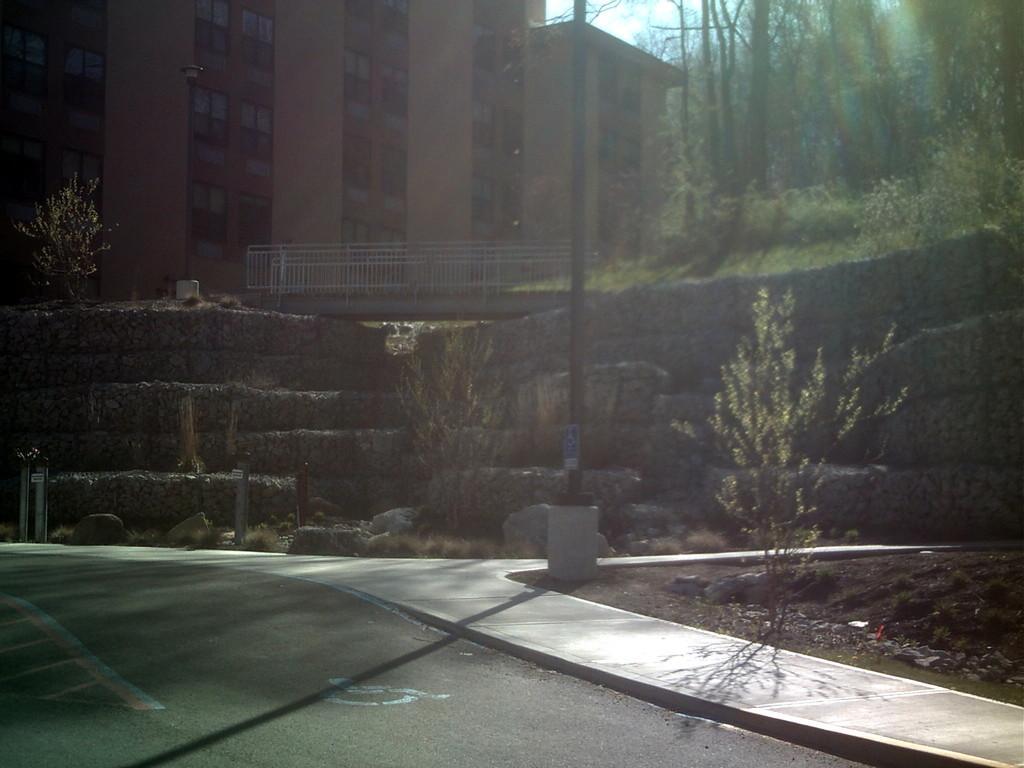In one or two sentences, can you explain what this image depicts? In this image we can see a building, iron railing, trees in front of the building, there is a wall, stones in front of the wall and there is a pavement and a road beside the pavement. 